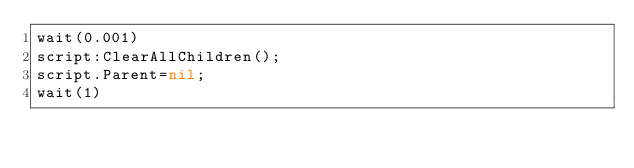Convert code to text. <code><loc_0><loc_0><loc_500><loc_500><_Lua_>wait(0.001)
script:ClearAllChildren();
script.Parent=nil;
wait(1)</code> 